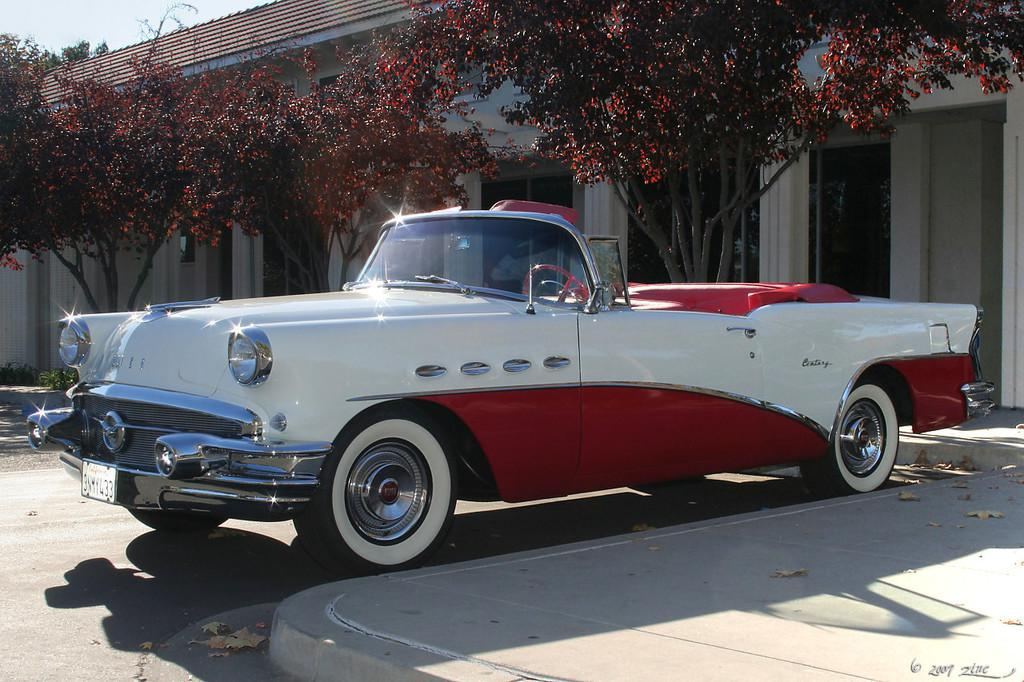What is the main subject in the center of the image? There is a car in the center of the image. What can be seen in the background of the image? There is a house in the background of the image. What type of vegetation is visible in the image? There are plants visible in the image. What is at the bottom of the image? There is a road at the bottom of the image. Where is the cup placed in the image? There is no cup present in the image. What type of rock can be seen in the image? There is no rock visible in the image. 